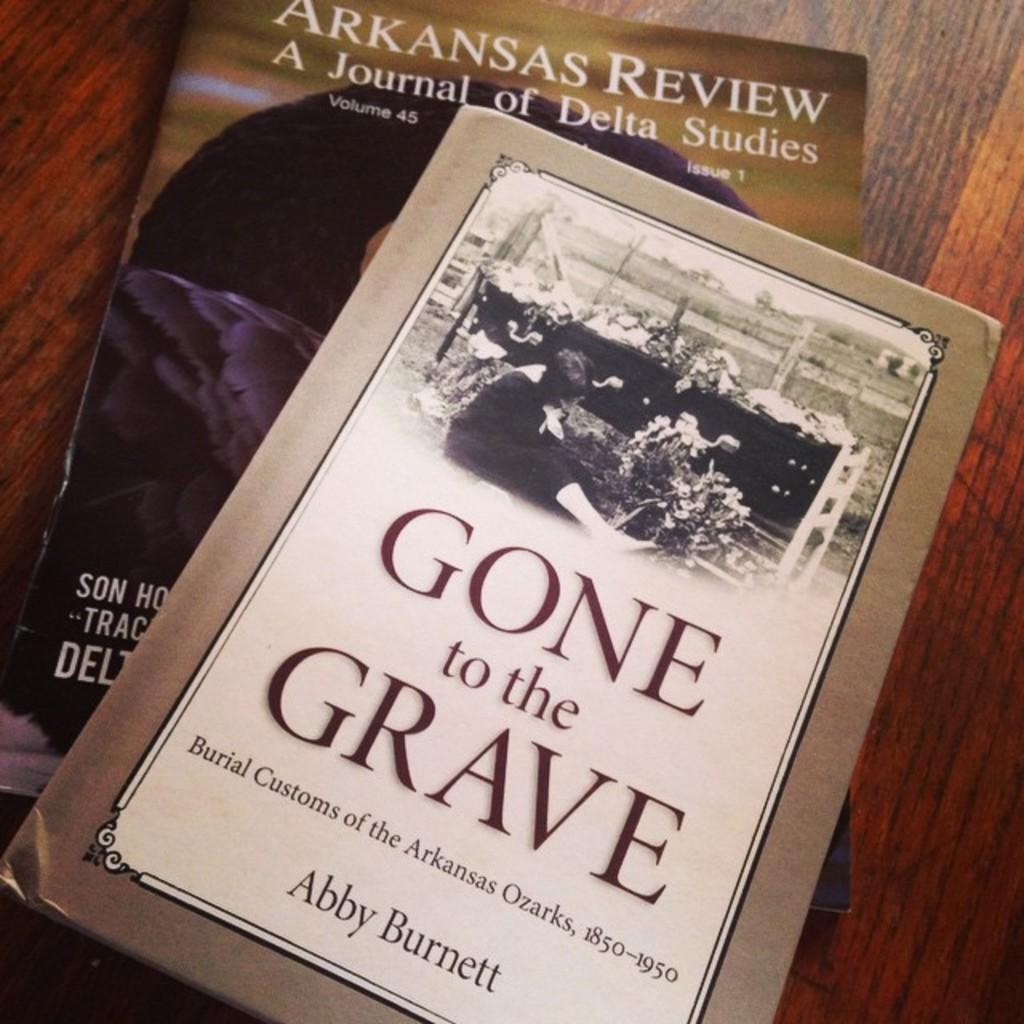<image>
Provide a brief description of the given image. Gone to the Grave book by Abby Burnett lying on top of another book that says Arkansas Review A Journal of Delta Studies. 